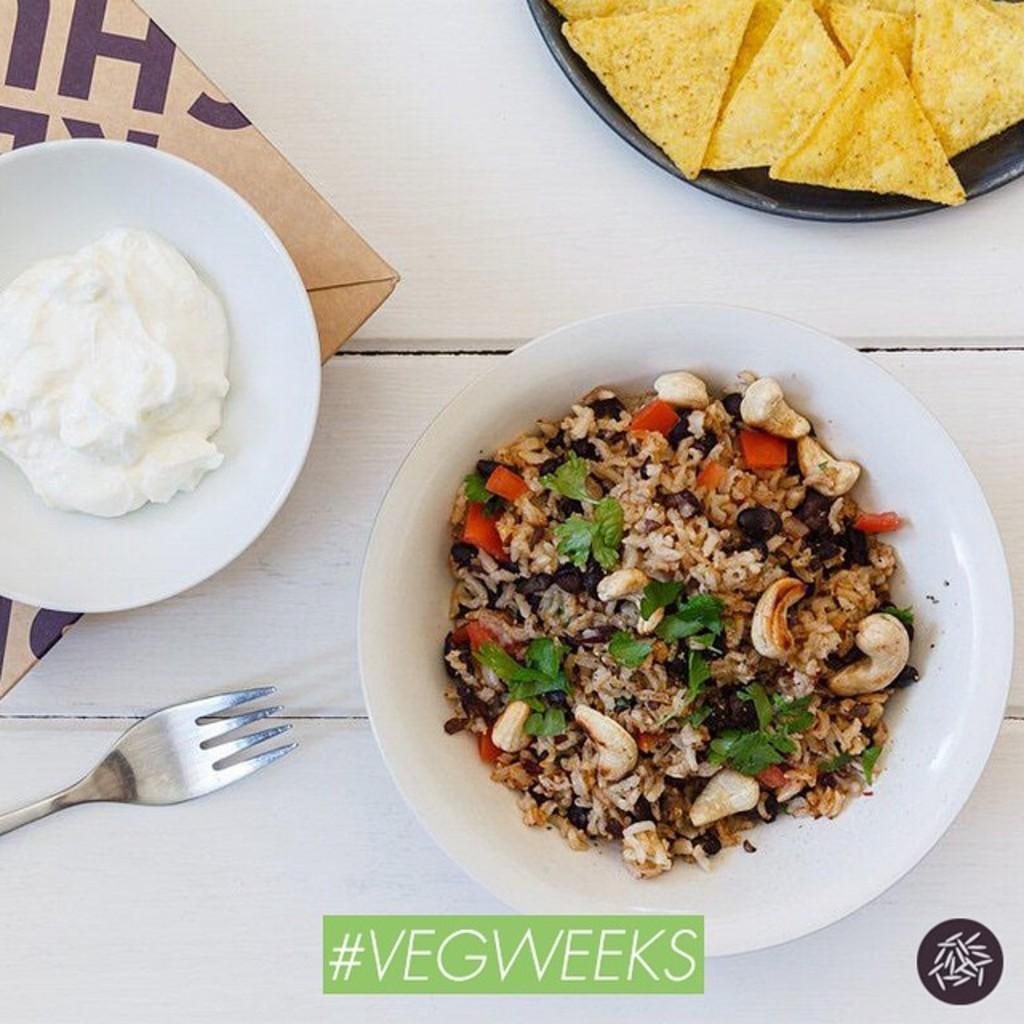Could you give a brief overview of what you see in this image? In the image we can see there is a rice and cashew nut food item kept in a plate and there is a fork. There is a cream kept in a plate and there are nachos kept in a bowl. The food item plates are kept on the plate. 